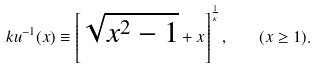<formula> <loc_0><loc_0><loc_500><loc_500>\ k u ^ { - 1 } ( x ) \equiv \left [ \sqrt { x ^ { 2 } - 1 } + x \right ] ^ { \frac { 1 } { \kappa } } , \quad ( x \geq 1 ) .</formula> 